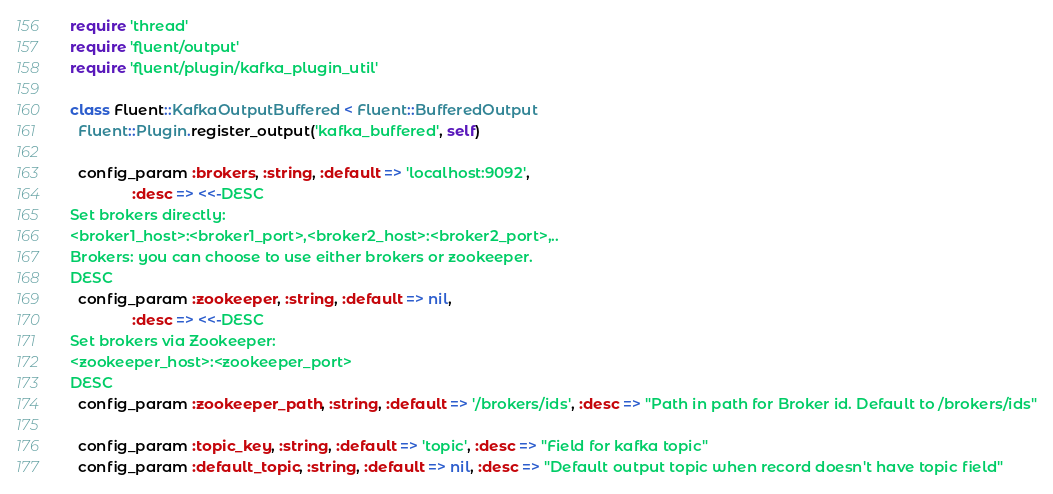<code> <loc_0><loc_0><loc_500><loc_500><_Ruby_>require 'thread'
require 'fluent/output'
require 'fluent/plugin/kafka_plugin_util'

class Fluent::KafkaOutputBuffered < Fluent::BufferedOutput
  Fluent::Plugin.register_output('kafka_buffered', self)

  config_param :brokers, :string, :default => 'localhost:9092',
               :desc => <<-DESC
Set brokers directly:
<broker1_host>:<broker1_port>,<broker2_host>:<broker2_port>,..
Brokers: you can choose to use either brokers or zookeeper.
DESC
  config_param :zookeeper, :string, :default => nil,
               :desc => <<-DESC
Set brokers via Zookeeper:
<zookeeper_host>:<zookeeper_port>
DESC
  config_param :zookeeper_path, :string, :default => '/brokers/ids', :desc => "Path in path for Broker id. Default to /brokers/ids"

  config_param :topic_key, :string, :default => 'topic', :desc => "Field for kafka topic"
  config_param :default_topic, :string, :default => nil, :desc => "Default output topic when record doesn't have topic field"</code> 